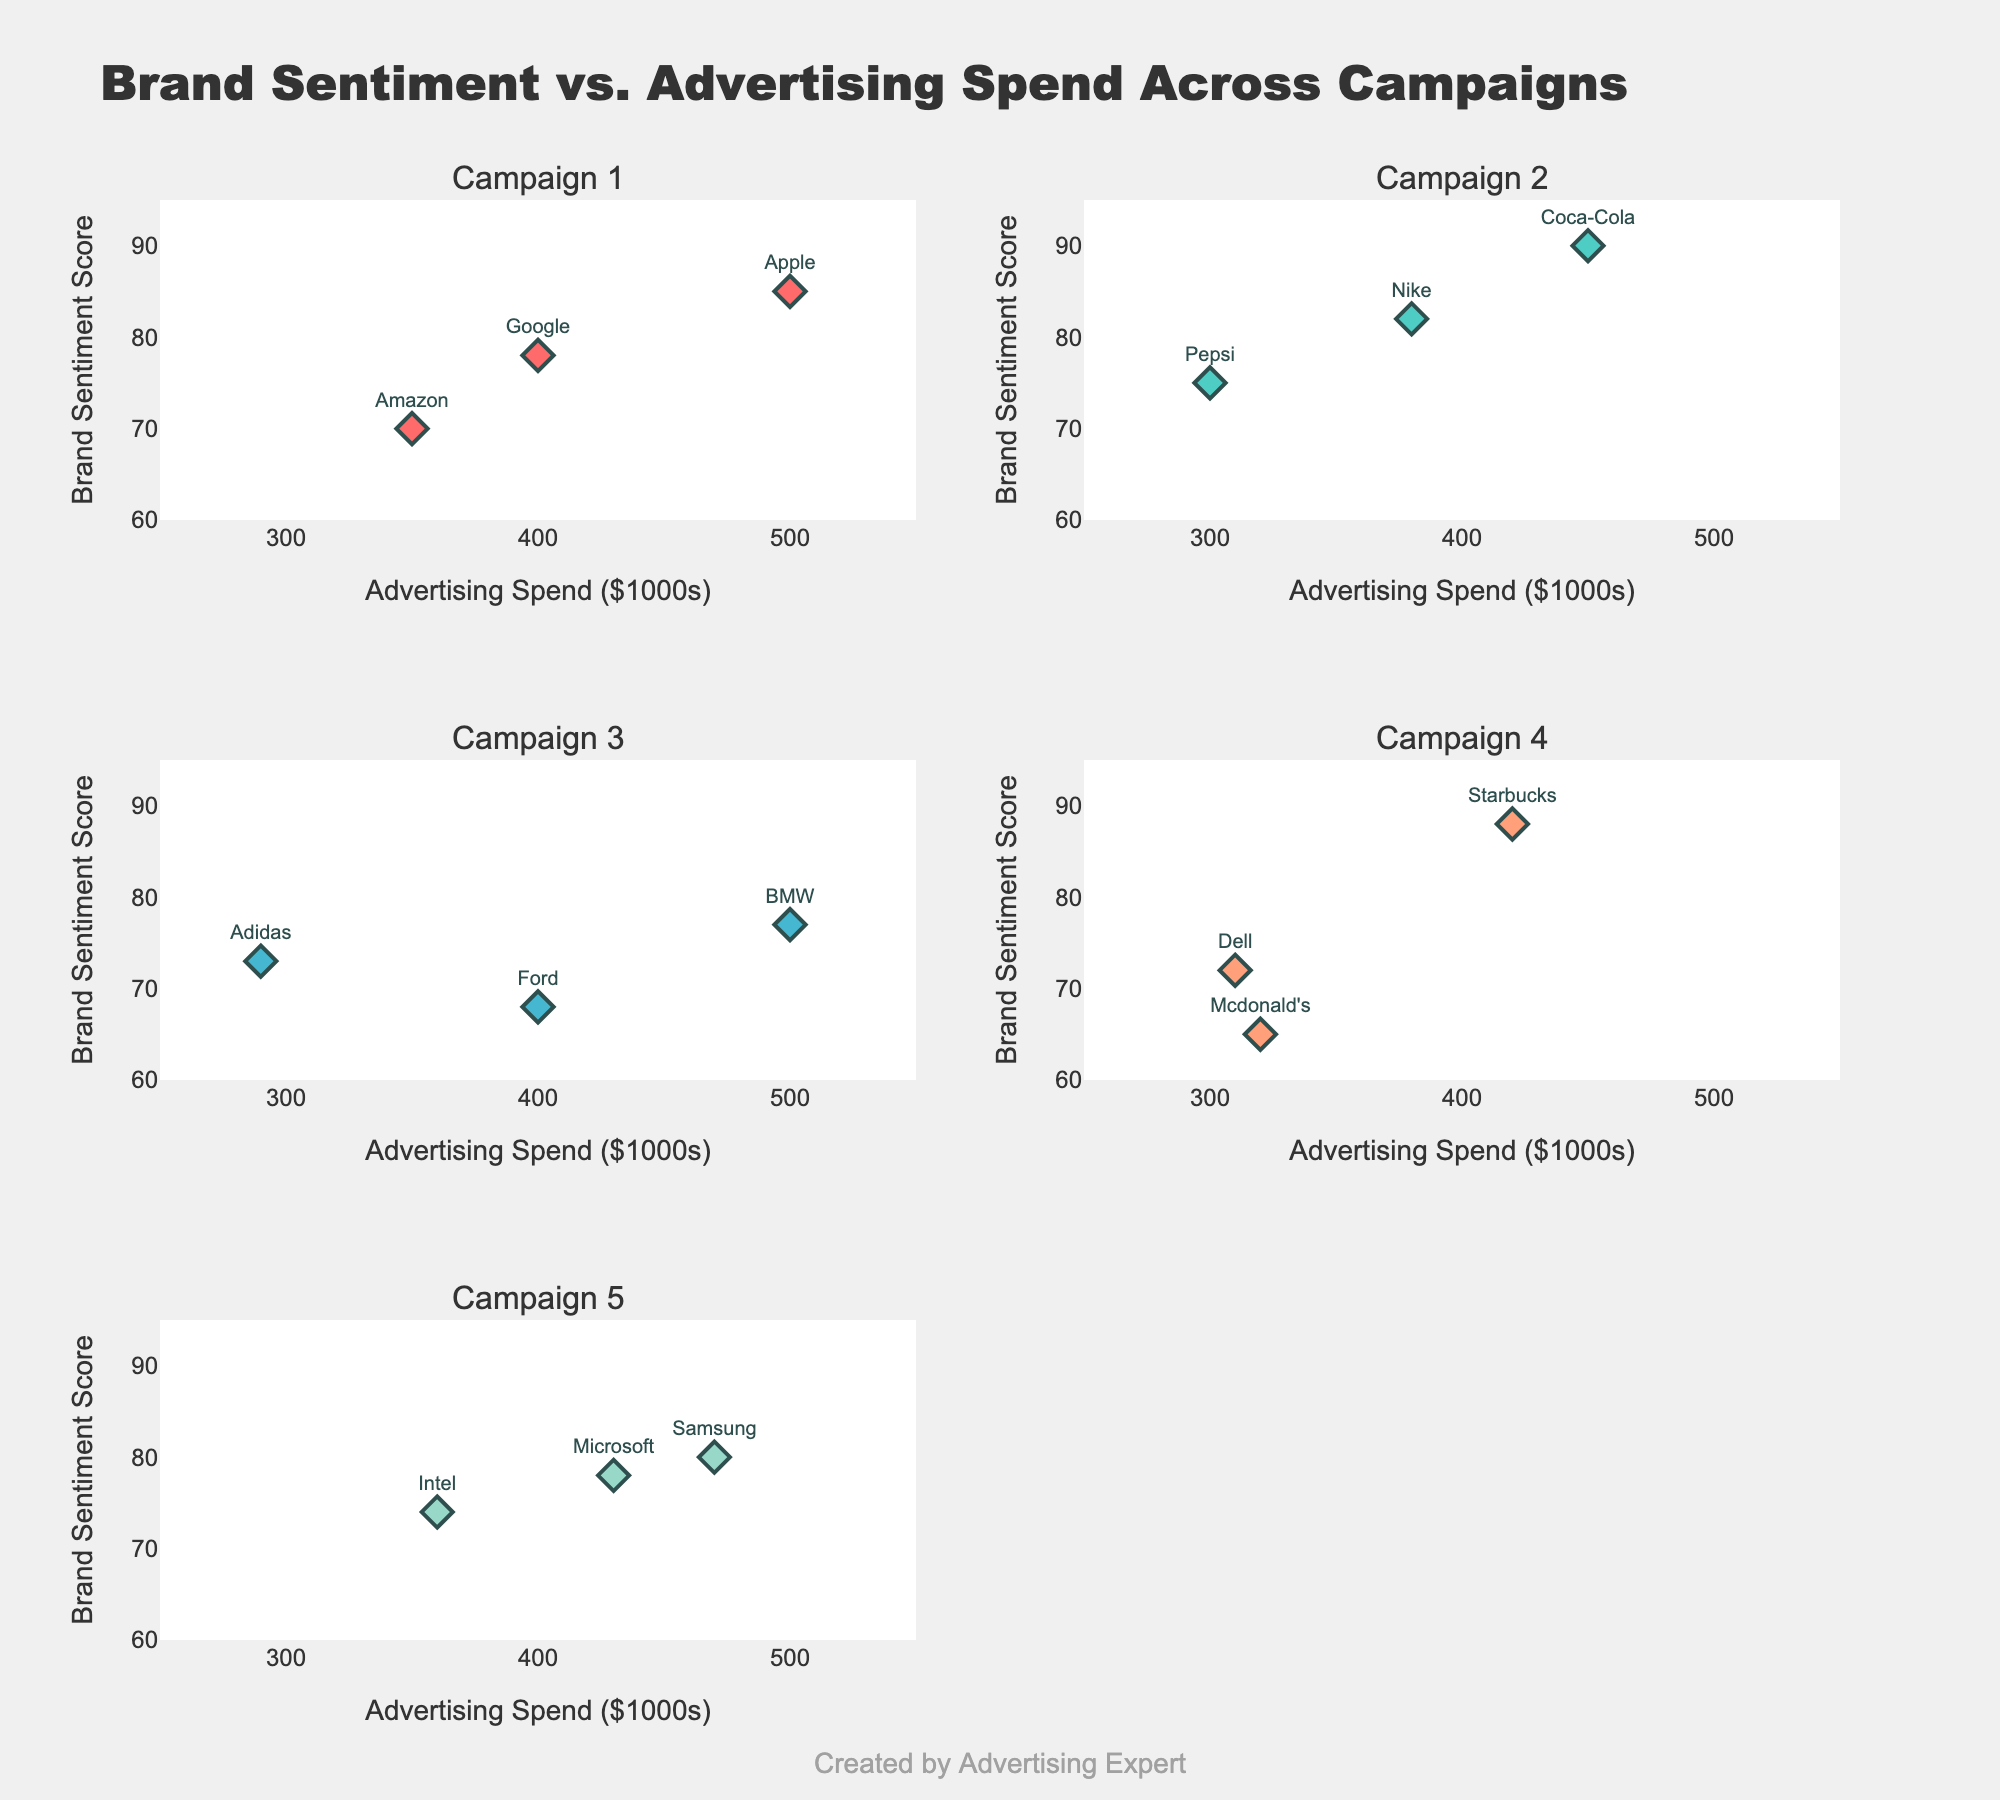What's the title of the figure? The title of the figure is clearly written at the top of the plot.
Answer: "Brand Sentiment vs. Advertising Spend Across Campaigns" How many campaigns are displayed in the figure? The subplot titles indicate the number of unique campaigns.
Answer: 5 Which brand has the highest sentiment score? By examining the y-axis values across all subplots, the highest sentiment score is associated with the brand closest to 95.
Answer: Coca-Cola What is the advertising spend for the campaign with the highest sentiment score? Identify the campaign with the highest sentiment score, which is Coca-Cola in Campaign 2, and then find the corresponding x-axis value.
Answer: 450 How many brands have a sentiment score above 80? Count the number of data points across all subplots where the y-axis value is greater than 80.
Answer: 6 In Campaign 1, which brand has the lowest advertising spend? For Campaign 1, compare the x-axis values and identify the brand with the lowest value.
Answer: Amazon Compare the sentiment scores between Apple and Google. Which one is higher? Locate the data points for Apple and Google and compare their y-axis values.
Answer: Apple What's the range of advertising spend for Campaign 4? Identify the minimum and maximum x-axis values for Campaign 4.
Answer: 310 to 420 Which campaign shows the highest advertising spend overall? Identify the subplot with the highest x-axis value, which corresponds to the maximum advertising spend.
Answer: Campaign 1 What's the average sentiment score across all brands in Campaign 5? Add the sentiment scores for all three brands in Campaign 5 and divide by 3.
Answer: 77.33 